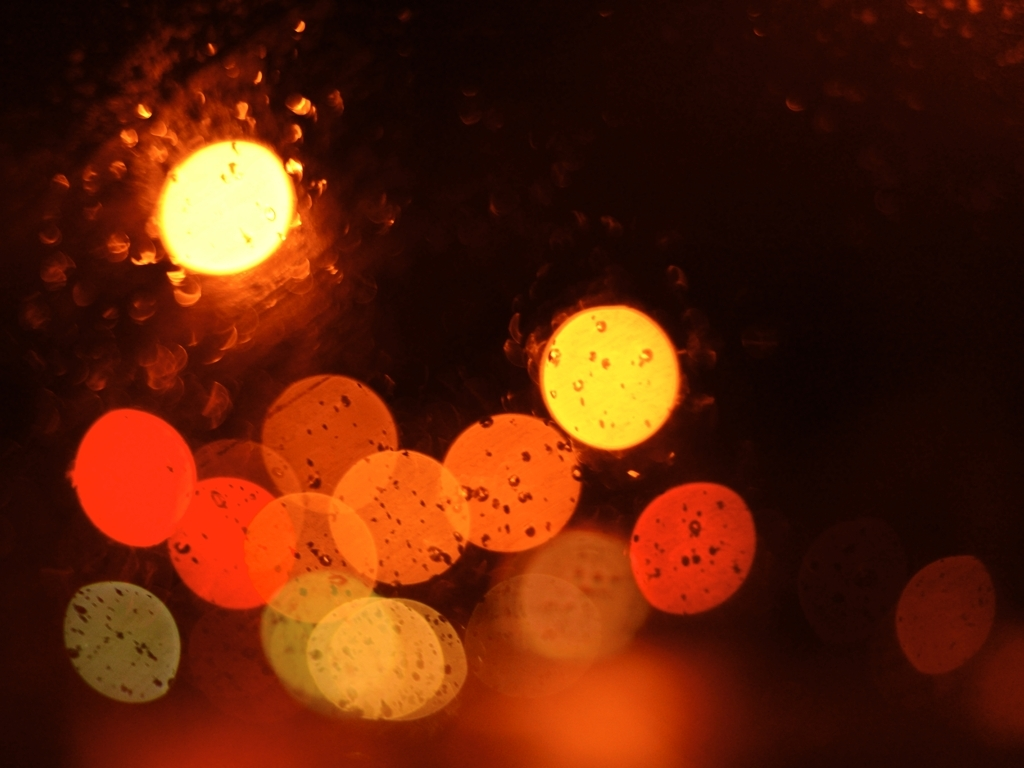Is the subject clear? The image depicts a bokeh effect of out-of-focus light sources, likely from a night-time cityscape seen through a moist surface. The subject is intentionally abstract and focuses on the play of light and shadow to create a mood rather than a clear depiction of specific objects. 